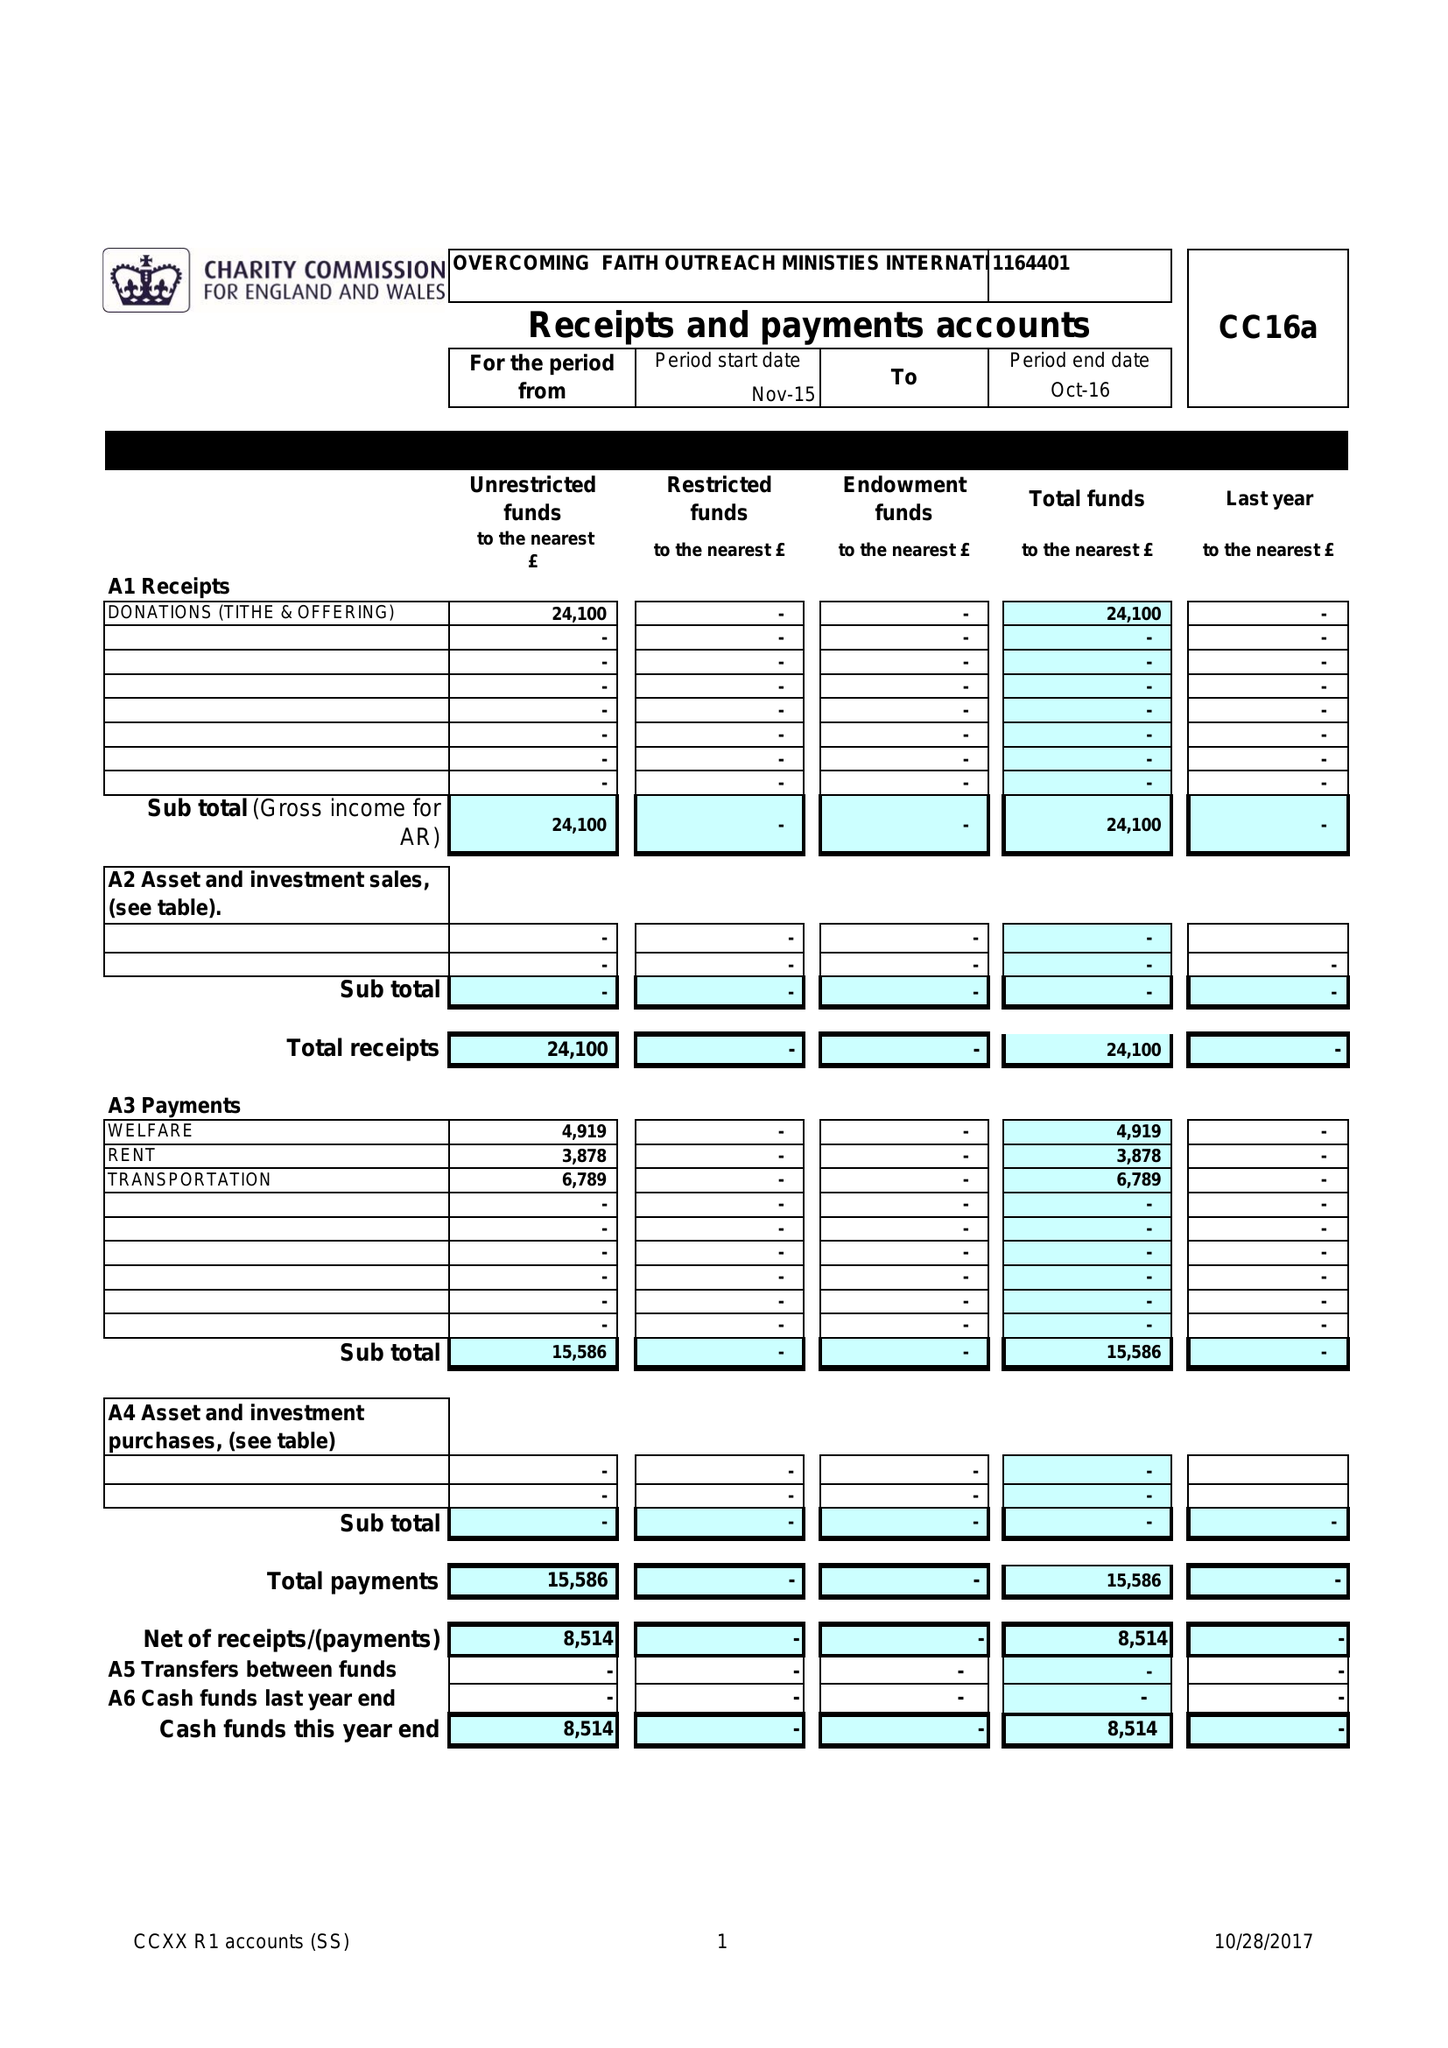What is the value for the charity_number?
Answer the question using a single word or phrase. 1164401 